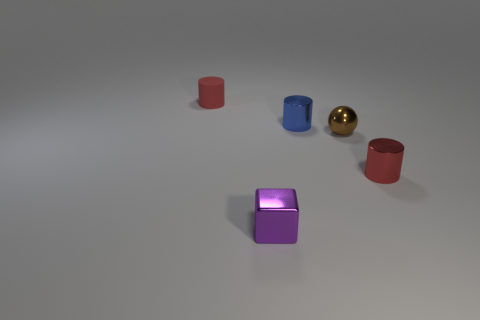Is there another metallic ball of the same size as the sphere?
Provide a short and direct response. No. What color is the block that is the same material as the small blue cylinder?
Make the answer very short. Purple. What is the sphere made of?
Give a very brief answer. Metal. There is a brown metallic thing; what shape is it?
Keep it short and to the point. Sphere. What number of other cylinders have the same color as the rubber cylinder?
Make the answer very short. 1. What is the tiny object that is in front of the red cylinder in front of the small red thing that is behind the small blue thing made of?
Give a very brief answer. Metal. How many red things are metallic objects or tiny metallic cubes?
Offer a terse response. 1. There is a cylinder that is to the right of the tiny shiny cylinder that is left of the red cylinder to the right of the purple thing; what is its size?
Provide a succinct answer. Small. There is another rubber object that is the same shape as the blue thing; what size is it?
Make the answer very short. Small. What number of small things are either purple metallic cubes or metal things?
Keep it short and to the point. 4. 